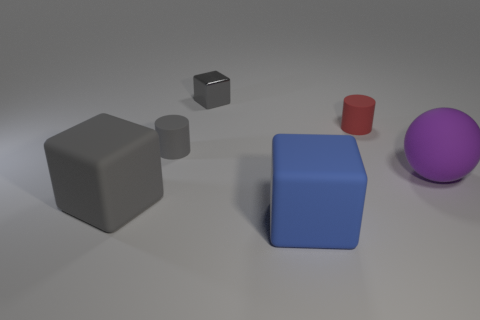Is the number of gray objects to the left of the gray rubber block less than the number of objects on the right side of the tiny gray shiny thing?
Offer a very short reply. Yes. What number of other things are the same shape as the big purple object?
Make the answer very short. 0. How big is the gray block left of the gray cube behind the large rubber object left of the gray matte cylinder?
Give a very brief answer. Large. What number of purple objects are either matte cubes or small objects?
Give a very brief answer. 0. The big rubber object that is behind the big gray thing to the left of the large blue matte block is what shape?
Provide a succinct answer. Sphere. There is a cube behind the small gray matte cylinder; is its size the same as the cylinder in front of the tiny red object?
Provide a succinct answer. Yes. Is there a tiny gray thing that has the same material as the blue thing?
Offer a terse response. Yes. There is a rubber cylinder that is the same color as the shiny thing; what is its size?
Your answer should be very brief. Small. There is a tiny cylinder that is to the left of the big cube on the right side of the tiny gray rubber cylinder; is there a small red object left of it?
Your answer should be very brief. No. Are there any purple objects in front of the large blue rubber block?
Give a very brief answer. No. 